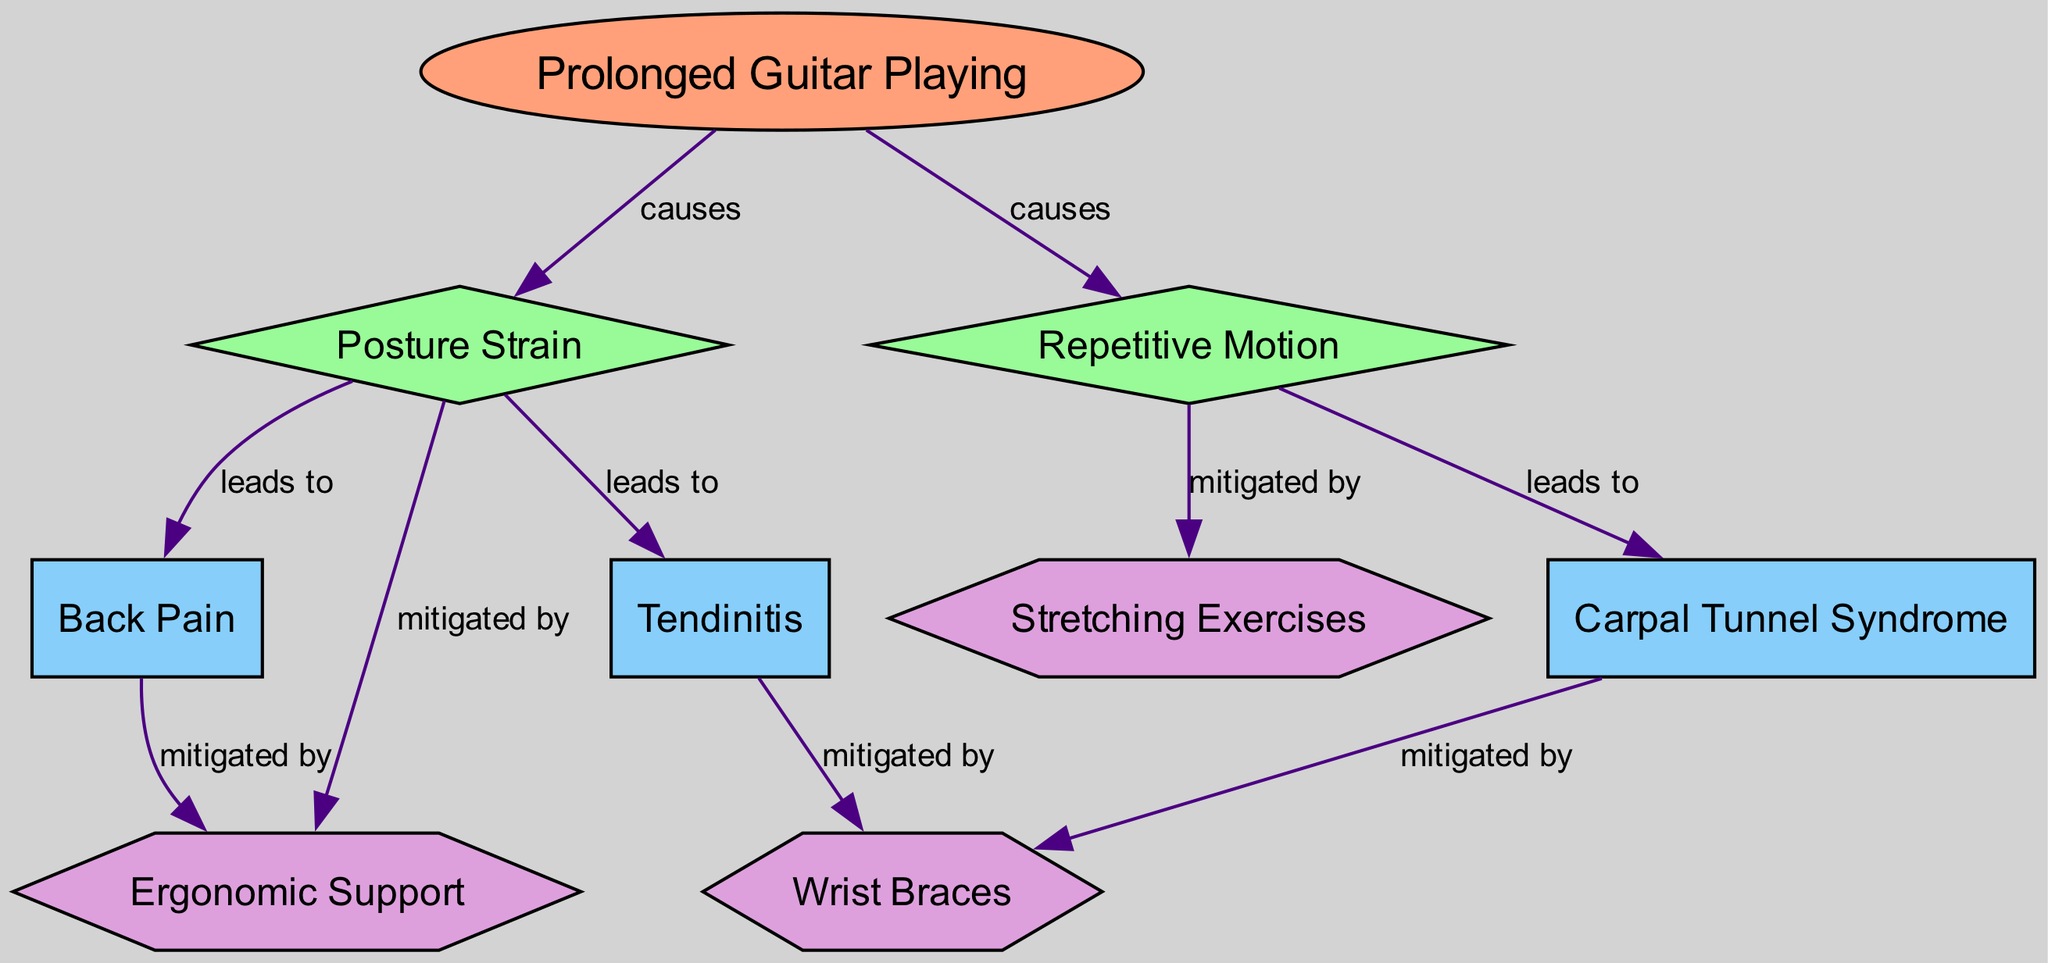What is the main activity discussed in the diagram? The diagram prominently features "Prolonged Guitar Playing" as the central activity. It is clearly labeled as the starting point in the diagram, indicating its significance in the context of musculoskeletal health.
Answer: Prolonged Guitar Playing How many conditions are listed in the diagram? By counting the labels categorized as conditions in the diagram, I identify three: Tendinitis, Carpal Tunnel Syndrome, and Back Pain. Thus, the total is three conditions.
Answer: 3 What leads to Tendinitis according to the diagram? The diagram shows that "Posture Strain" leads to "Tendinitis." This relationship is indicated by a directed edge labeled "leads to," directly connecting the two nodes and illustrating the causality.
Answer: Posture Strain Which prevention method is associated with Back Pain? The diagram specifies that "Back Pain" can be mitigated by "Ergonomic Support." This relationship is explicitly indicated with a directed edge labeled "mitigated by," connecting Back Pain to Ergonomic Support.
Answer: Ergonomic Support What two causes are associated with Prolonged Guitar Playing? The diagram outlines that "Posture Strain" and "Repetitive Motion" are both causes linked to "Prolonged Guitar Playing." These connections are depicted with directed edges leading from the activity node to both of these cause nodes.
Answer: Posture Strain, Repetitive Motion How does Repetitive Motion relate to Carpal Tunnel Syndrome? In the diagram, "Repetitive Motion" directly leads to "Carpal Tunnel Syndrome," as shown by the directional edge labeled "leads to." This suggests that repetitive actions in guitar playing could result in this condition.
Answer: Leads to What prevention method is linked to both Tendinitis and Carpal Tunnel Syndrome? The diagram indicates "Wrist Braces" as a prevention method that helps mitigate both "Tendinitis" and "Carpal Tunnel Syndrome." This is shown by the bi-directional relationships labeled "mitigated by."
Answer: Wrist Braces Which cause can be mitigated by Stretching Exercises? The diagram shows that "Repetitive Motion" can be mitigated by "Stretching Exercises." This relationship is clearly stated with a directed edge leading from Repetitive Motion to Stretching Exercises.
Answer: Stretching Exercises 